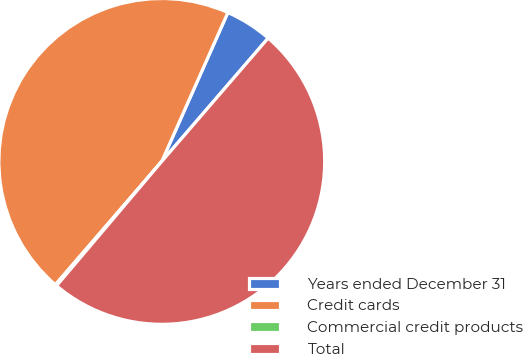Convert chart. <chart><loc_0><loc_0><loc_500><loc_500><pie_chart><fcel>Years ended December 31<fcel>Credit cards<fcel>Commercial credit products<fcel>Total<nl><fcel>4.68%<fcel>45.32%<fcel>0.15%<fcel>49.85%<nl></chart> 